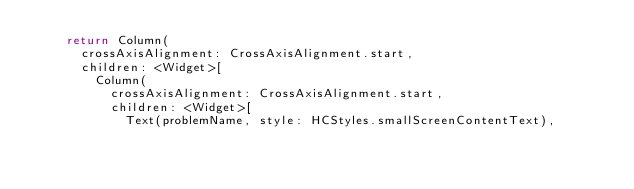<code> <loc_0><loc_0><loc_500><loc_500><_Dart_>    return Column(
      crossAxisAlignment: CrossAxisAlignment.start,
      children: <Widget>[
        Column(
          crossAxisAlignment: CrossAxisAlignment.start,
          children: <Widget>[
            Text(problemName, style: HCStyles.smallScreenContentText),</code> 